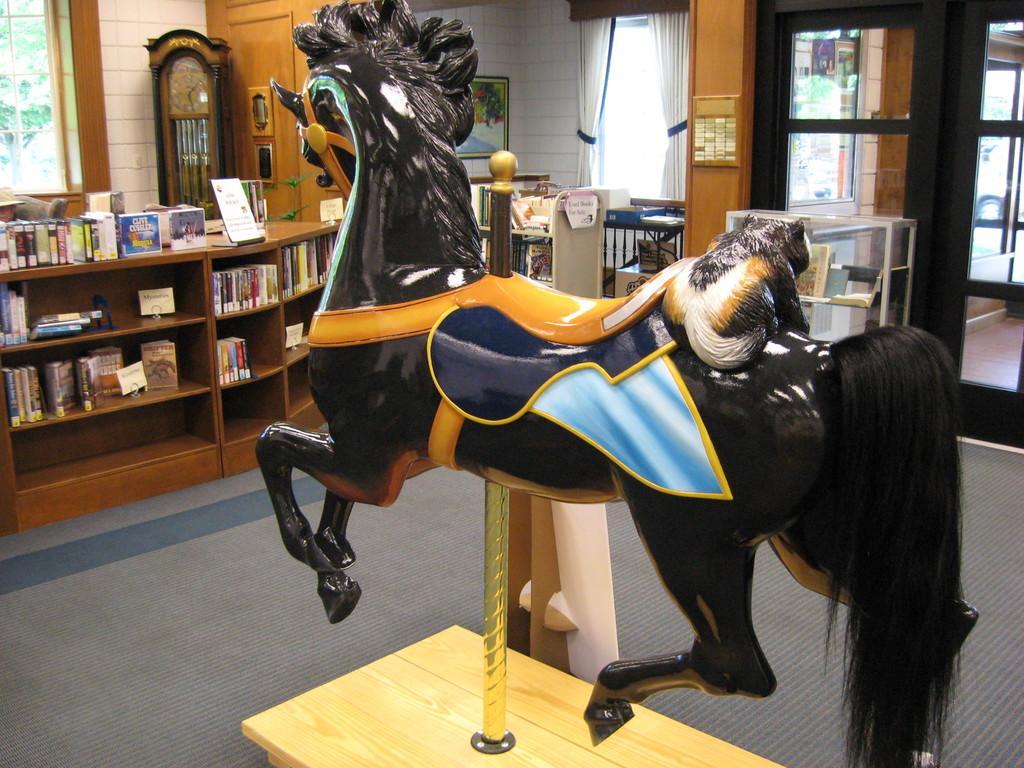Can you describe this image briefly? In this image in front there is a depiction of a horse. At the bottom of the image there is a mat. On the left side of the image there are books on the wooden rack. There is a clock. There is a window. On the right side of the image there is a door. There are curtains. In the background of the image there is a wall with the photo frames on it. 